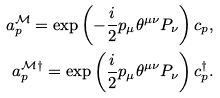Convert formula to latex. <formula><loc_0><loc_0><loc_500><loc_500>a ^ { \mathcal { M } } _ { p } = \exp \left ( { - \frac { i } { 2 } p _ { \mu } \theta ^ { \mu \nu } P _ { \nu } } \right ) c _ { p } , \\ a ^ { \mathcal { M } \dagger } _ { p } = \exp \left ( { \frac { i } { 2 } p _ { \mu } \theta ^ { \mu \nu } P _ { \nu } } \right ) c _ { p } ^ { \dagger } .</formula> 